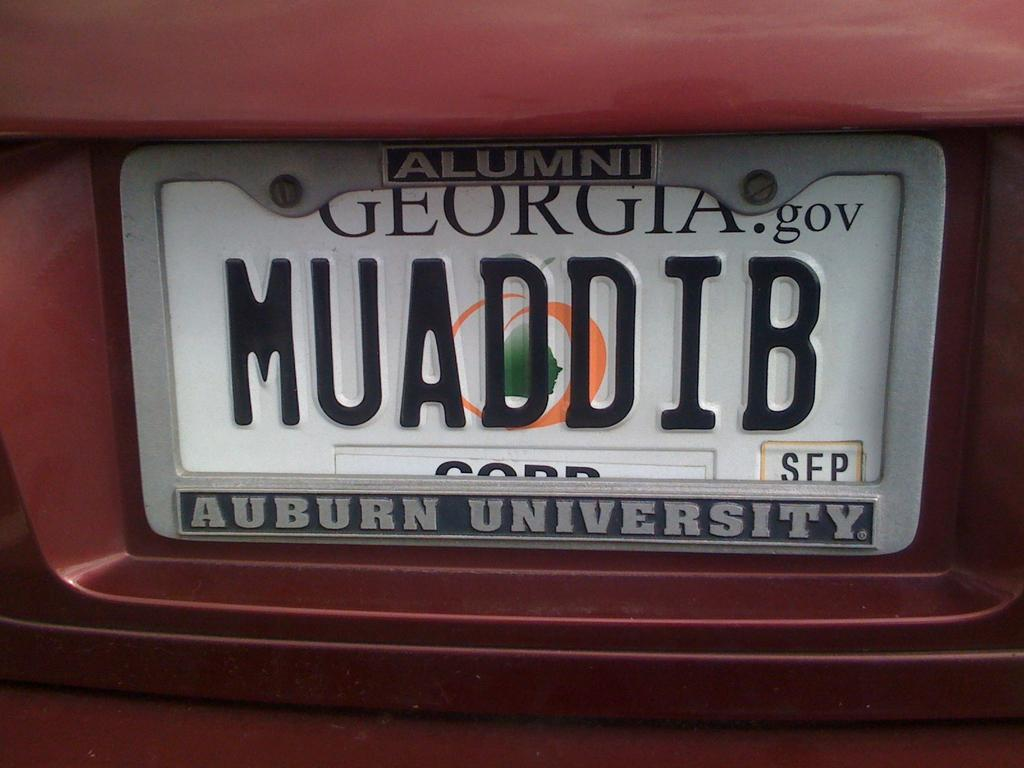<image>
Summarize the visual content of the image. A Georgia license plate is shown, with an Auburn University Alumni frame. 